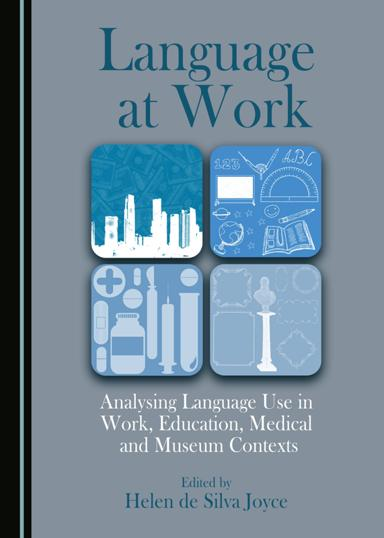What is the title of the book mentioned in the image? The title of the book displayed in the image is "Language at Work: Analysing Language Use in Work, Education, Medical and Museum Contexts." This book offers extensive insights into how language functions in various professional settings, providing valuable perspectives for those interested in linguistics and communication. 